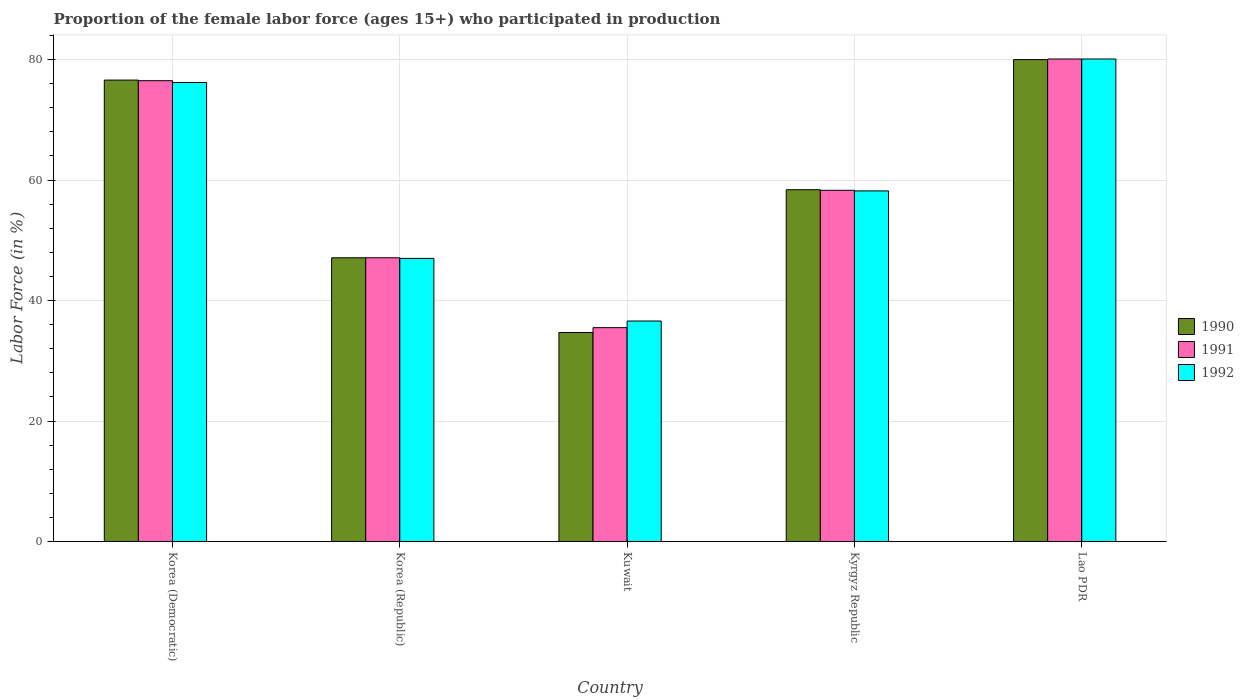How many different coloured bars are there?
Keep it short and to the point. 3. How many groups of bars are there?
Offer a very short reply. 5. Are the number of bars per tick equal to the number of legend labels?
Offer a terse response. Yes. Are the number of bars on each tick of the X-axis equal?
Your response must be concise. Yes. How many bars are there on the 3rd tick from the left?
Your response must be concise. 3. How many bars are there on the 3rd tick from the right?
Ensure brevity in your answer.  3. What is the label of the 2nd group of bars from the left?
Keep it short and to the point. Korea (Republic). Across all countries, what is the maximum proportion of the female labor force who participated in production in 1991?
Your answer should be very brief. 80.1. Across all countries, what is the minimum proportion of the female labor force who participated in production in 1992?
Your answer should be compact. 36.6. In which country was the proportion of the female labor force who participated in production in 1990 maximum?
Ensure brevity in your answer.  Lao PDR. In which country was the proportion of the female labor force who participated in production in 1991 minimum?
Offer a terse response. Kuwait. What is the total proportion of the female labor force who participated in production in 1990 in the graph?
Your response must be concise. 296.8. What is the difference between the proportion of the female labor force who participated in production in 1990 in Korea (Democratic) and that in Lao PDR?
Provide a succinct answer. -3.4. What is the difference between the proportion of the female labor force who participated in production in 1990 in Kuwait and the proportion of the female labor force who participated in production in 1991 in Lao PDR?
Provide a succinct answer. -45.4. What is the average proportion of the female labor force who participated in production in 1990 per country?
Your answer should be compact. 59.36. What is the difference between the proportion of the female labor force who participated in production of/in 1991 and proportion of the female labor force who participated in production of/in 1990 in Korea (Democratic)?
Offer a terse response. -0.1. In how many countries, is the proportion of the female labor force who participated in production in 1991 greater than 24 %?
Your response must be concise. 5. What is the ratio of the proportion of the female labor force who participated in production in 1992 in Kuwait to that in Kyrgyz Republic?
Make the answer very short. 0.63. Is the proportion of the female labor force who participated in production in 1991 in Kuwait less than that in Kyrgyz Republic?
Give a very brief answer. Yes. What is the difference between the highest and the second highest proportion of the female labor force who participated in production in 1990?
Your answer should be very brief. 21.6. What is the difference between the highest and the lowest proportion of the female labor force who participated in production in 1992?
Your answer should be very brief. 43.5. Is the sum of the proportion of the female labor force who participated in production in 1992 in Korea (Democratic) and Lao PDR greater than the maximum proportion of the female labor force who participated in production in 1991 across all countries?
Offer a terse response. Yes. What does the 3rd bar from the right in Kuwait represents?
Your answer should be very brief. 1990. How many countries are there in the graph?
Give a very brief answer. 5. What is the difference between two consecutive major ticks on the Y-axis?
Make the answer very short. 20. Does the graph contain grids?
Offer a very short reply. Yes. Where does the legend appear in the graph?
Make the answer very short. Center right. How many legend labels are there?
Offer a terse response. 3. What is the title of the graph?
Your answer should be compact. Proportion of the female labor force (ages 15+) who participated in production. Does "1983" appear as one of the legend labels in the graph?
Make the answer very short. No. What is the Labor Force (in %) of 1990 in Korea (Democratic)?
Give a very brief answer. 76.6. What is the Labor Force (in %) in 1991 in Korea (Democratic)?
Offer a very short reply. 76.5. What is the Labor Force (in %) of 1992 in Korea (Democratic)?
Offer a very short reply. 76.2. What is the Labor Force (in %) in 1990 in Korea (Republic)?
Ensure brevity in your answer.  47.1. What is the Labor Force (in %) of 1991 in Korea (Republic)?
Your response must be concise. 47.1. What is the Labor Force (in %) of 1990 in Kuwait?
Provide a short and direct response. 34.7. What is the Labor Force (in %) of 1991 in Kuwait?
Your answer should be very brief. 35.5. What is the Labor Force (in %) in 1992 in Kuwait?
Offer a terse response. 36.6. What is the Labor Force (in %) of 1990 in Kyrgyz Republic?
Your answer should be compact. 58.4. What is the Labor Force (in %) of 1991 in Kyrgyz Republic?
Give a very brief answer. 58.3. What is the Labor Force (in %) in 1992 in Kyrgyz Republic?
Keep it short and to the point. 58.2. What is the Labor Force (in %) of 1990 in Lao PDR?
Give a very brief answer. 80. What is the Labor Force (in %) in 1991 in Lao PDR?
Provide a short and direct response. 80.1. What is the Labor Force (in %) of 1992 in Lao PDR?
Provide a succinct answer. 80.1. Across all countries, what is the maximum Labor Force (in %) in 1990?
Keep it short and to the point. 80. Across all countries, what is the maximum Labor Force (in %) of 1991?
Provide a short and direct response. 80.1. Across all countries, what is the maximum Labor Force (in %) in 1992?
Offer a terse response. 80.1. Across all countries, what is the minimum Labor Force (in %) in 1990?
Offer a terse response. 34.7. Across all countries, what is the minimum Labor Force (in %) of 1991?
Offer a terse response. 35.5. Across all countries, what is the minimum Labor Force (in %) of 1992?
Provide a succinct answer. 36.6. What is the total Labor Force (in %) of 1990 in the graph?
Your answer should be very brief. 296.8. What is the total Labor Force (in %) of 1991 in the graph?
Your answer should be compact. 297.5. What is the total Labor Force (in %) in 1992 in the graph?
Provide a short and direct response. 298.1. What is the difference between the Labor Force (in %) of 1990 in Korea (Democratic) and that in Korea (Republic)?
Give a very brief answer. 29.5. What is the difference between the Labor Force (in %) of 1991 in Korea (Democratic) and that in Korea (Republic)?
Your response must be concise. 29.4. What is the difference between the Labor Force (in %) in 1992 in Korea (Democratic) and that in Korea (Republic)?
Offer a terse response. 29.2. What is the difference between the Labor Force (in %) in 1990 in Korea (Democratic) and that in Kuwait?
Give a very brief answer. 41.9. What is the difference between the Labor Force (in %) of 1991 in Korea (Democratic) and that in Kuwait?
Your answer should be very brief. 41. What is the difference between the Labor Force (in %) of 1992 in Korea (Democratic) and that in Kuwait?
Your response must be concise. 39.6. What is the difference between the Labor Force (in %) in 1990 in Korea (Democratic) and that in Kyrgyz Republic?
Provide a succinct answer. 18.2. What is the difference between the Labor Force (in %) in 1991 in Korea (Democratic) and that in Kyrgyz Republic?
Make the answer very short. 18.2. What is the difference between the Labor Force (in %) of 1992 in Korea (Democratic) and that in Kyrgyz Republic?
Your answer should be compact. 18. What is the difference between the Labor Force (in %) in 1991 in Korea (Republic) and that in Kuwait?
Give a very brief answer. 11.6. What is the difference between the Labor Force (in %) of 1990 in Korea (Republic) and that in Kyrgyz Republic?
Ensure brevity in your answer.  -11.3. What is the difference between the Labor Force (in %) in 1992 in Korea (Republic) and that in Kyrgyz Republic?
Provide a succinct answer. -11.2. What is the difference between the Labor Force (in %) in 1990 in Korea (Republic) and that in Lao PDR?
Offer a very short reply. -32.9. What is the difference between the Labor Force (in %) in 1991 in Korea (Republic) and that in Lao PDR?
Your response must be concise. -33. What is the difference between the Labor Force (in %) of 1992 in Korea (Republic) and that in Lao PDR?
Make the answer very short. -33.1. What is the difference between the Labor Force (in %) in 1990 in Kuwait and that in Kyrgyz Republic?
Provide a succinct answer. -23.7. What is the difference between the Labor Force (in %) of 1991 in Kuwait and that in Kyrgyz Republic?
Keep it short and to the point. -22.8. What is the difference between the Labor Force (in %) in 1992 in Kuwait and that in Kyrgyz Republic?
Offer a very short reply. -21.6. What is the difference between the Labor Force (in %) in 1990 in Kuwait and that in Lao PDR?
Your response must be concise. -45.3. What is the difference between the Labor Force (in %) in 1991 in Kuwait and that in Lao PDR?
Your answer should be very brief. -44.6. What is the difference between the Labor Force (in %) in 1992 in Kuwait and that in Lao PDR?
Give a very brief answer. -43.5. What is the difference between the Labor Force (in %) in 1990 in Kyrgyz Republic and that in Lao PDR?
Provide a succinct answer. -21.6. What is the difference between the Labor Force (in %) in 1991 in Kyrgyz Republic and that in Lao PDR?
Provide a short and direct response. -21.8. What is the difference between the Labor Force (in %) of 1992 in Kyrgyz Republic and that in Lao PDR?
Ensure brevity in your answer.  -21.9. What is the difference between the Labor Force (in %) in 1990 in Korea (Democratic) and the Labor Force (in %) in 1991 in Korea (Republic)?
Keep it short and to the point. 29.5. What is the difference between the Labor Force (in %) of 1990 in Korea (Democratic) and the Labor Force (in %) of 1992 in Korea (Republic)?
Offer a terse response. 29.6. What is the difference between the Labor Force (in %) in 1991 in Korea (Democratic) and the Labor Force (in %) in 1992 in Korea (Republic)?
Keep it short and to the point. 29.5. What is the difference between the Labor Force (in %) of 1990 in Korea (Democratic) and the Labor Force (in %) of 1991 in Kuwait?
Keep it short and to the point. 41.1. What is the difference between the Labor Force (in %) in 1990 in Korea (Democratic) and the Labor Force (in %) in 1992 in Kuwait?
Make the answer very short. 40. What is the difference between the Labor Force (in %) in 1991 in Korea (Democratic) and the Labor Force (in %) in 1992 in Kuwait?
Provide a succinct answer. 39.9. What is the difference between the Labor Force (in %) in 1990 in Korea (Democratic) and the Labor Force (in %) in 1991 in Kyrgyz Republic?
Your answer should be very brief. 18.3. What is the difference between the Labor Force (in %) of 1991 in Korea (Democratic) and the Labor Force (in %) of 1992 in Kyrgyz Republic?
Your answer should be very brief. 18.3. What is the difference between the Labor Force (in %) in 1990 in Korea (Democratic) and the Labor Force (in %) in 1991 in Lao PDR?
Your response must be concise. -3.5. What is the difference between the Labor Force (in %) in 1991 in Korea (Democratic) and the Labor Force (in %) in 1992 in Lao PDR?
Ensure brevity in your answer.  -3.6. What is the difference between the Labor Force (in %) in 1990 in Korea (Republic) and the Labor Force (in %) in 1991 in Kuwait?
Offer a very short reply. 11.6. What is the difference between the Labor Force (in %) of 1990 in Korea (Republic) and the Labor Force (in %) of 1992 in Kuwait?
Offer a terse response. 10.5. What is the difference between the Labor Force (in %) in 1990 in Korea (Republic) and the Labor Force (in %) in 1991 in Kyrgyz Republic?
Your answer should be compact. -11.2. What is the difference between the Labor Force (in %) of 1991 in Korea (Republic) and the Labor Force (in %) of 1992 in Kyrgyz Republic?
Make the answer very short. -11.1. What is the difference between the Labor Force (in %) in 1990 in Korea (Republic) and the Labor Force (in %) in 1991 in Lao PDR?
Your answer should be compact. -33. What is the difference between the Labor Force (in %) in 1990 in Korea (Republic) and the Labor Force (in %) in 1992 in Lao PDR?
Ensure brevity in your answer.  -33. What is the difference between the Labor Force (in %) in 1991 in Korea (Republic) and the Labor Force (in %) in 1992 in Lao PDR?
Ensure brevity in your answer.  -33. What is the difference between the Labor Force (in %) of 1990 in Kuwait and the Labor Force (in %) of 1991 in Kyrgyz Republic?
Provide a succinct answer. -23.6. What is the difference between the Labor Force (in %) in 1990 in Kuwait and the Labor Force (in %) in 1992 in Kyrgyz Republic?
Ensure brevity in your answer.  -23.5. What is the difference between the Labor Force (in %) of 1991 in Kuwait and the Labor Force (in %) of 1992 in Kyrgyz Republic?
Ensure brevity in your answer.  -22.7. What is the difference between the Labor Force (in %) of 1990 in Kuwait and the Labor Force (in %) of 1991 in Lao PDR?
Make the answer very short. -45.4. What is the difference between the Labor Force (in %) in 1990 in Kuwait and the Labor Force (in %) in 1992 in Lao PDR?
Offer a very short reply. -45.4. What is the difference between the Labor Force (in %) in 1991 in Kuwait and the Labor Force (in %) in 1992 in Lao PDR?
Ensure brevity in your answer.  -44.6. What is the difference between the Labor Force (in %) of 1990 in Kyrgyz Republic and the Labor Force (in %) of 1991 in Lao PDR?
Provide a short and direct response. -21.7. What is the difference between the Labor Force (in %) in 1990 in Kyrgyz Republic and the Labor Force (in %) in 1992 in Lao PDR?
Your answer should be compact. -21.7. What is the difference between the Labor Force (in %) in 1991 in Kyrgyz Republic and the Labor Force (in %) in 1992 in Lao PDR?
Give a very brief answer. -21.8. What is the average Labor Force (in %) of 1990 per country?
Ensure brevity in your answer.  59.36. What is the average Labor Force (in %) in 1991 per country?
Provide a succinct answer. 59.5. What is the average Labor Force (in %) in 1992 per country?
Offer a very short reply. 59.62. What is the difference between the Labor Force (in %) in 1990 and Labor Force (in %) in 1991 in Korea (Democratic)?
Make the answer very short. 0.1. What is the difference between the Labor Force (in %) in 1990 and Labor Force (in %) in 1992 in Korea (Republic)?
Keep it short and to the point. 0.1. What is the difference between the Labor Force (in %) of 1990 and Labor Force (in %) of 1991 in Kuwait?
Your answer should be very brief. -0.8. What is the difference between the Labor Force (in %) in 1990 and Labor Force (in %) in 1992 in Kuwait?
Your response must be concise. -1.9. What is the difference between the Labor Force (in %) in 1990 and Labor Force (in %) in 1991 in Kyrgyz Republic?
Make the answer very short. 0.1. What is the difference between the Labor Force (in %) of 1990 and Labor Force (in %) of 1992 in Kyrgyz Republic?
Give a very brief answer. 0.2. What is the difference between the Labor Force (in %) of 1990 and Labor Force (in %) of 1991 in Lao PDR?
Give a very brief answer. -0.1. What is the difference between the Labor Force (in %) in 1990 and Labor Force (in %) in 1992 in Lao PDR?
Your answer should be compact. -0.1. What is the ratio of the Labor Force (in %) of 1990 in Korea (Democratic) to that in Korea (Republic)?
Offer a terse response. 1.63. What is the ratio of the Labor Force (in %) of 1991 in Korea (Democratic) to that in Korea (Republic)?
Ensure brevity in your answer.  1.62. What is the ratio of the Labor Force (in %) in 1992 in Korea (Democratic) to that in Korea (Republic)?
Offer a terse response. 1.62. What is the ratio of the Labor Force (in %) of 1990 in Korea (Democratic) to that in Kuwait?
Provide a short and direct response. 2.21. What is the ratio of the Labor Force (in %) of 1991 in Korea (Democratic) to that in Kuwait?
Provide a succinct answer. 2.15. What is the ratio of the Labor Force (in %) in 1992 in Korea (Democratic) to that in Kuwait?
Offer a very short reply. 2.08. What is the ratio of the Labor Force (in %) of 1990 in Korea (Democratic) to that in Kyrgyz Republic?
Offer a very short reply. 1.31. What is the ratio of the Labor Force (in %) of 1991 in Korea (Democratic) to that in Kyrgyz Republic?
Provide a succinct answer. 1.31. What is the ratio of the Labor Force (in %) in 1992 in Korea (Democratic) to that in Kyrgyz Republic?
Give a very brief answer. 1.31. What is the ratio of the Labor Force (in %) in 1990 in Korea (Democratic) to that in Lao PDR?
Keep it short and to the point. 0.96. What is the ratio of the Labor Force (in %) of 1991 in Korea (Democratic) to that in Lao PDR?
Make the answer very short. 0.96. What is the ratio of the Labor Force (in %) of 1992 in Korea (Democratic) to that in Lao PDR?
Your response must be concise. 0.95. What is the ratio of the Labor Force (in %) of 1990 in Korea (Republic) to that in Kuwait?
Provide a succinct answer. 1.36. What is the ratio of the Labor Force (in %) of 1991 in Korea (Republic) to that in Kuwait?
Give a very brief answer. 1.33. What is the ratio of the Labor Force (in %) in 1992 in Korea (Republic) to that in Kuwait?
Provide a succinct answer. 1.28. What is the ratio of the Labor Force (in %) in 1990 in Korea (Republic) to that in Kyrgyz Republic?
Your response must be concise. 0.81. What is the ratio of the Labor Force (in %) of 1991 in Korea (Republic) to that in Kyrgyz Republic?
Offer a very short reply. 0.81. What is the ratio of the Labor Force (in %) of 1992 in Korea (Republic) to that in Kyrgyz Republic?
Make the answer very short. 0.81. What is the ratio of the Labor Force (in %) in 1990 in Korea (Republic) to that in Lao PDR?
Keep it short and to the point. 0.59. What is the ratio of the Labor Force (in %) of 1991 in Korea (Republic) to that in Lao PDR?
Offer a terse response. 0.59. What is the ratio of the Labor Force (in %) of 1992 in Korea (Republic) to that in Lao PDR?
Your answer should be compact. 0.59. What is the ratio of the Labor Force (in %) in 1990 in Kuwait to that in Kyrgyz Republic?
Your response must be concise. 0.59. What is the ratio of the Labor Force (in %) in 1991 in Kuwait to that in Kyrgyz Republic?
Offer a very short reply. 0.61. What is the ratio of the Labor Force (in %) of 1992 in Kuwait to that in Kyrgyz Republic?
Your response must be concise. 0.63. What is the ratio of the Labor Force (in %) in 1990 in Kuwait to that in Lao PDR?
Ensure brevity in your answer.  0.43. What is the ratio of the Labor Force (in %) in 1991 in Kuwait to that in Lao PDR?
Your response must be concise. 0.44. What is the ratio of the Labor Force (in %) of 1992 in Kuwait to that in Lao PDR?
Offer a very short reply. 0.46. What is the ratio of the Labor Force (in %) in 1990 in Kyrgyz Republic to that in Lao PDR?
Offer a terse response. 0.73. What is the ratio of the Labor Force (in %) in 1991 in Kyrgyz Republic to that in Lao PDR?
Provide a short and direct response. 0.73. What is the ratio of the Labor Force (in %) in 1992 in Kyrgyz Republic to that in Lao PDR?
Make the answer very short. 0.73. What is the difference between the highest and the second highest Labor Force (in %) of 1991?
Make the answer very short. 3.6. What is the difference between the highest and the second highest Labor Force (in %) of 1992?
Your response must be concise. 3.9. What is the difference between the highest and the lowest Labor Force (in %) of 1990?
Your answer should be very brief. 45.3. What is the difference between the highest and the lowest Labor Force (in %) of 1991?
Your answer should be compact. 44.6. What is the difference between the highest and the lowest Labor Force (in %) of 1992?
Keep it short and to the point. 43.5. 